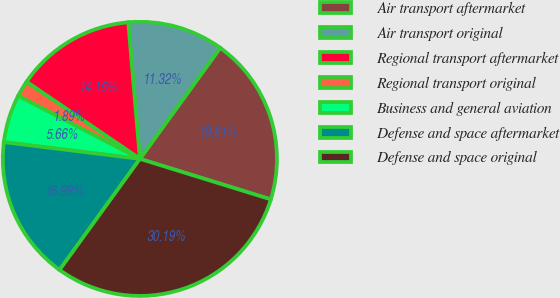<chart> <loc_0><loc_0><loc_500><loc_500><pie_chart><fcel>Air transport aftermarket<fcel>Air transport original<fcel>Regional transport aftermarket<fcel>Regional transport original<fcel>Business and general aviation<fcel>Defense and space aftermarket<fcel>Defense and space original<nl><fcel>19.81%<fcel>11.32%<fcel>14.15%<fcel>1.89%<fcel>5.66%<fcel>16.98%<fcel>30.19%<nl></chart> 